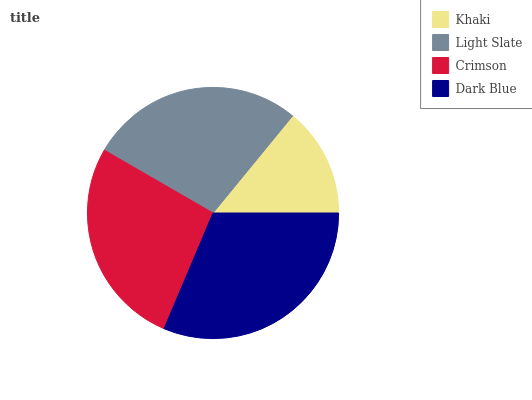Is Khaki the minimum?
Answer yes or no. Yes. Is Dark Blue the maximum?
Answer yes or no. Yes. Is Light Slate the minimum?
Answer yes or no. No. Is Light Slate the maximum?
Answer yes or no. No. Is Light Slate greater than Khaki?
Answer yes or no. Yes. Is Khaki less than Light Slate?
Answer yes or no. Yes. Is Khaki greater than Light Slate?
Answer yes or no. No. Is Light Slate less than Khaki?
Answer yes or no. No. Is Light Slate the high median?
Answer yes or no. Yes. Is Crimson the low median?
Answer yes or no. Yes. Is Khaki the high median?
Answer yes or no. No. Is Dark Blue the low median?
Answer yes or no. No. 